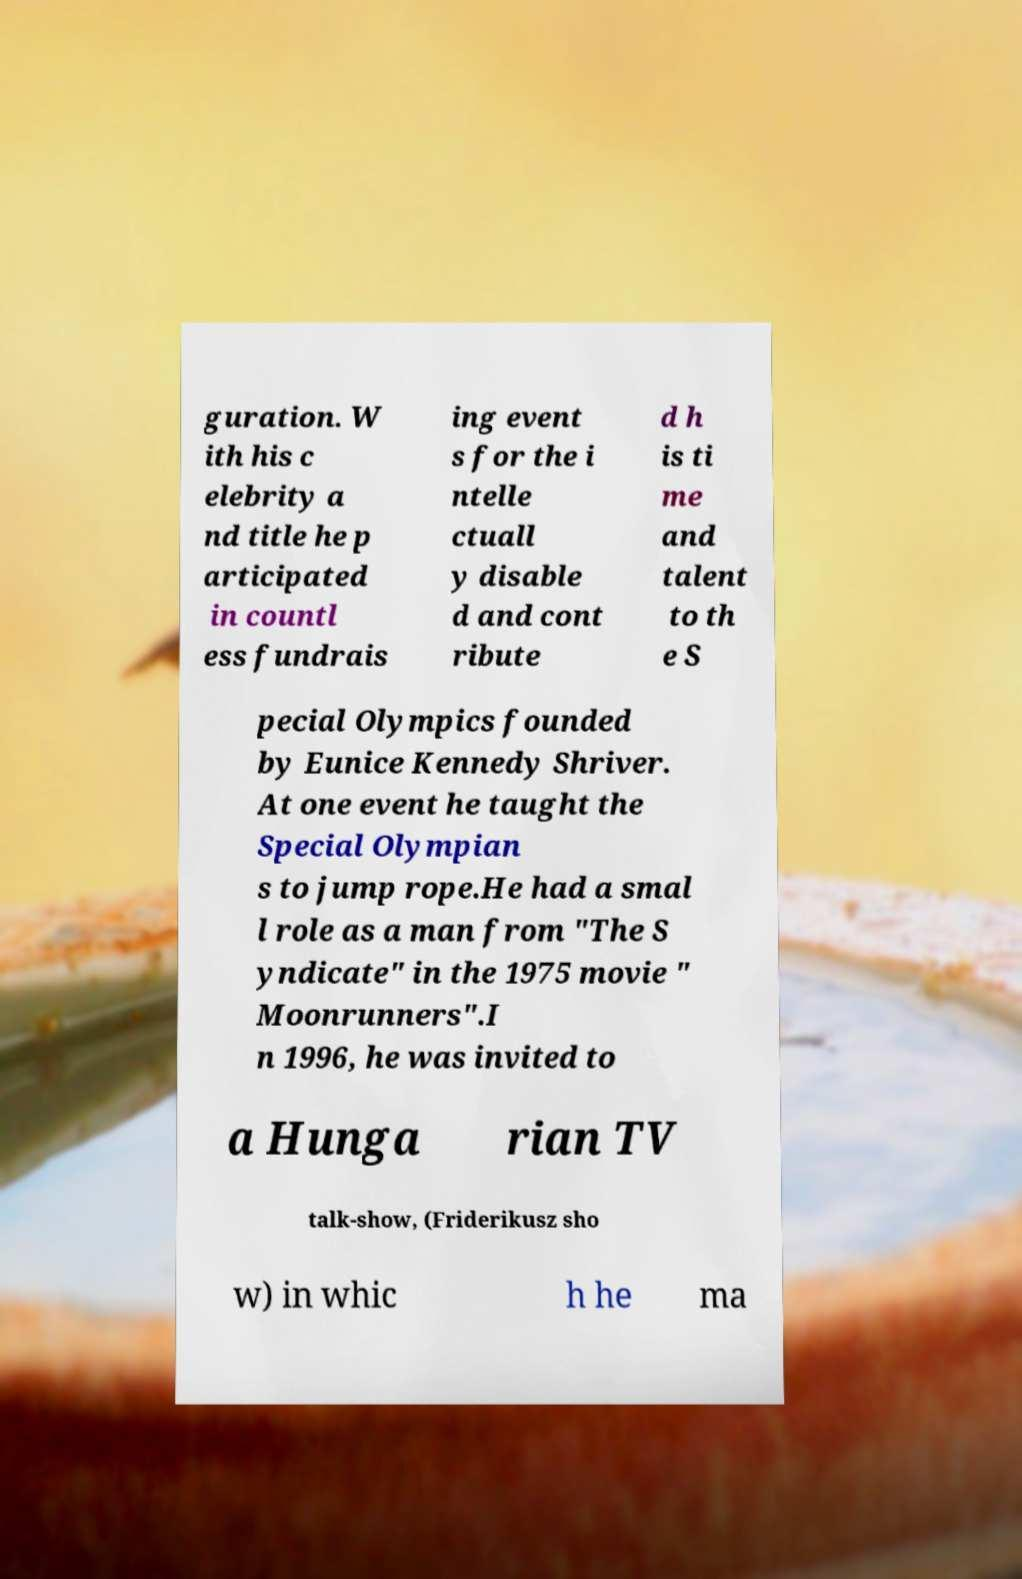Could you assist in decoding the text presented in this image and type it out clearly? guration. W ith his c elebrity a nd title he p articipated in countl ess fundrais ing event s for the i ntelle ctuall y disable d and cont ribute d h is ti me and talent to th e S pecial Olympics founded by Eunice Kennedy Shriver. At one event he taught the Special Olympian s to jump rope.He had a smal l role as a man from "The S yndicate" in the 1975 movie " Moonrunners".I n 1996, he was invited to a Hunga rian TV talk-show, (Friderikusz sho w) in whic h he ma 